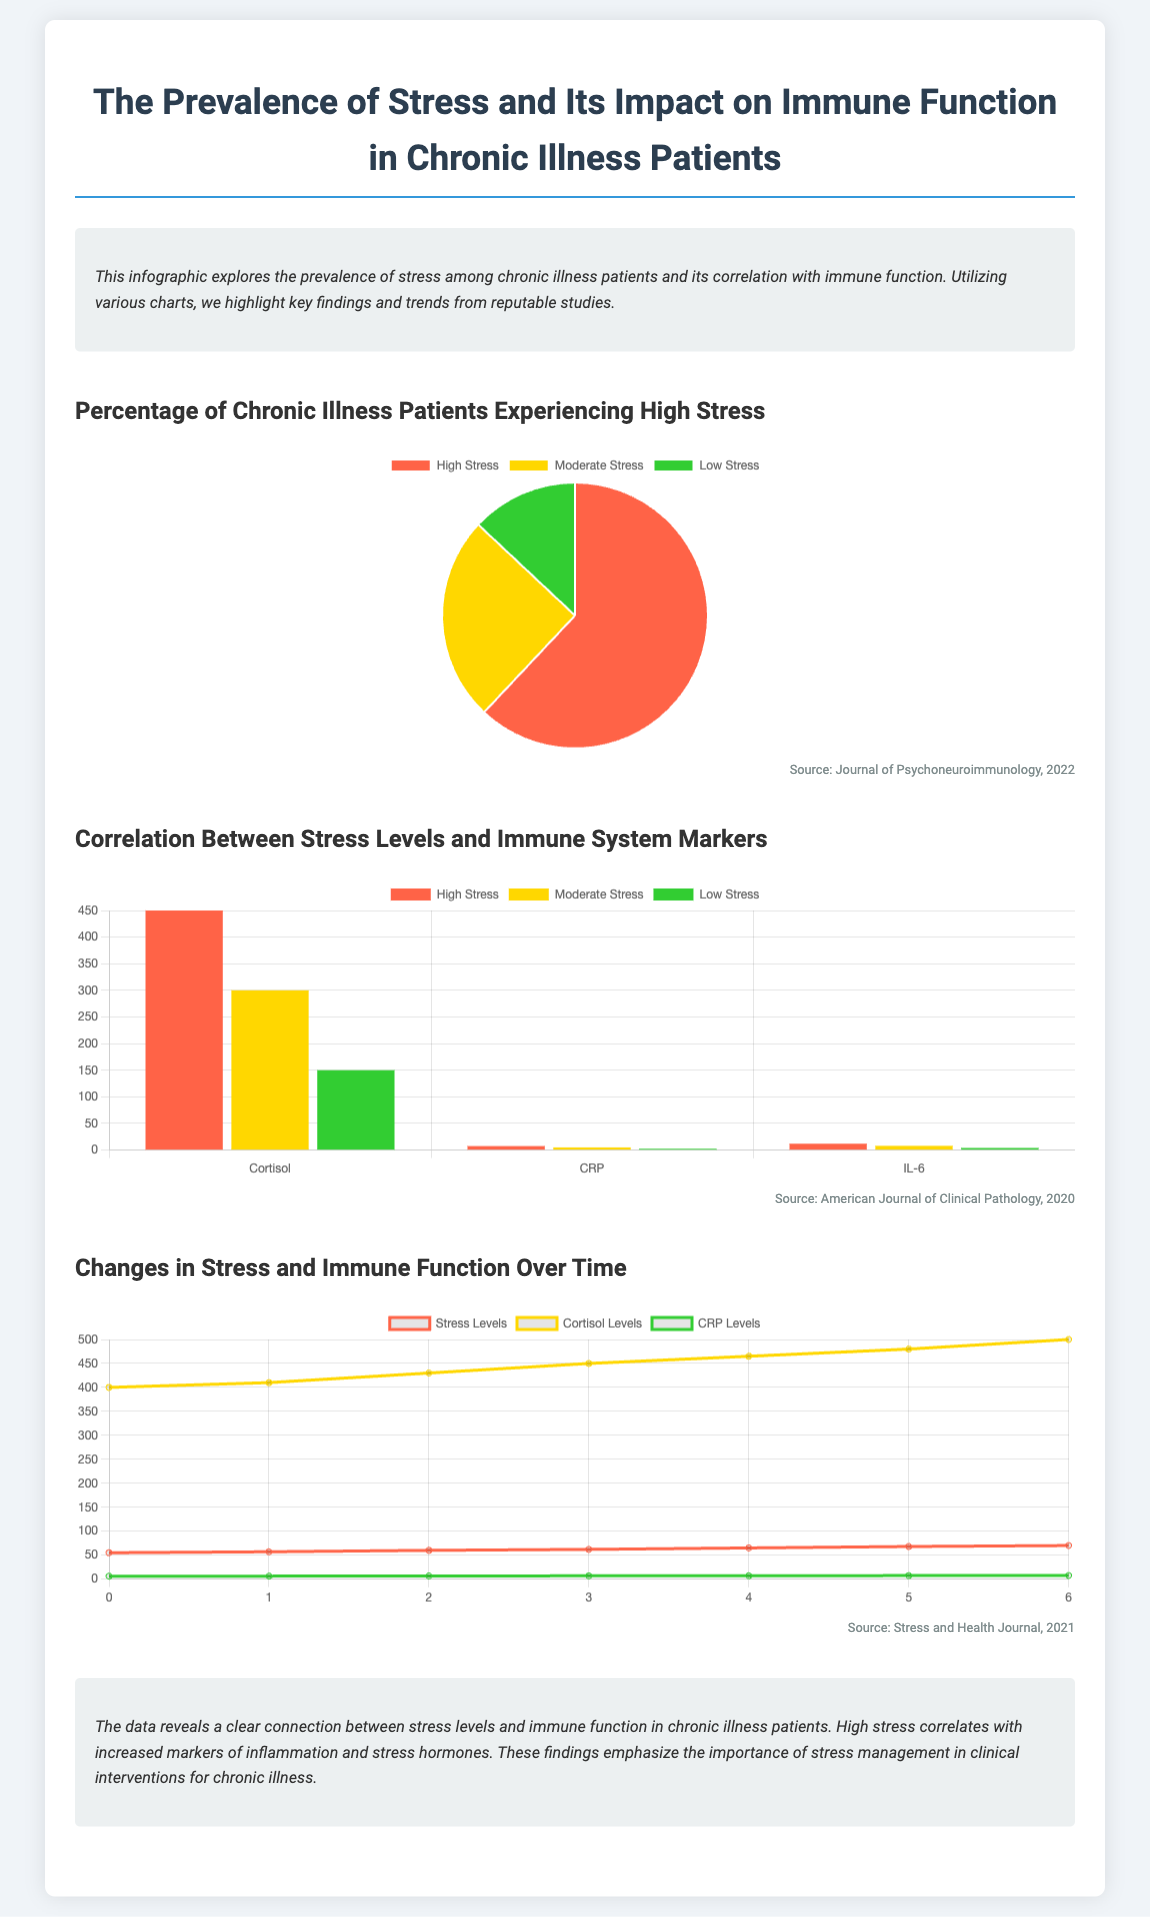What percentage of chronic illness patients experience high stress? The pie chart indicates that 62% of chronic illness patients report experiencing high stress.
Answer: 62% What immune system marker has the highest level in patients with high stress? The bar chart shows that cortisol levels are the highest among high stress patients at 450.
Answer: 450 What is the average CRP level for patients with moderate stress? The bar chart indicates that the average CRP level for moderate stress patients is 5.0.
Answer: 5.0 How many months are tracked in the line chart? The line chart tracks stress and immune function changes over 7 months, labeled from 0 to 6.
Answer: 7 What trend is observed in stress levels over time according to the line chart? The line chart shows an increasing trend in stress levels over time.
Answer: Increasing Which journal is cited as the source for the correlation between stress levels and immune system markers? The document identifies the American Journal of Clinical Pathology, 2020 as the source.
Answer: American Journal of Clinical Pathology, 2020 What color represents low stress in the pie chart? The pie chart uses green (#32CD32) to represent low stress.
Answer: Green What marker shows a consistent increase in levels over the tracked months? The line chart indicates that cortisol levels consistently increase over the tracked months.
Answer: Cortisol 